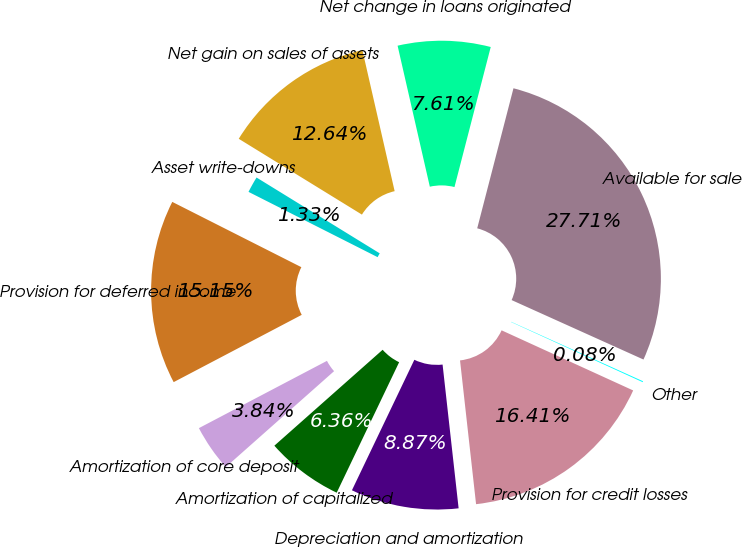<chart> <loc_0><loc_0><loc_500><loc_500><pie_chart><fcel>Provision for credit losses<fcel>Depreciation and amortization<fcel>Amortization of capitalized<fcel>Amortization of core deposit<fcel>Provision for deferred income<fcel>Asset write-downs<fcel>Net gain on sales of assets<fcel>Net change in loans originated<fcel>Available for sale<fcel>Other<nl><fcel>16.41%<fcel>8.87%<fcel>6.36%<fcel>3.84%<fcel>15.15%<fcel>1.33%<fcel>12.64%<fcel>7.61%<fcel>27.71%<fcel>0.08%<nl></chart> 